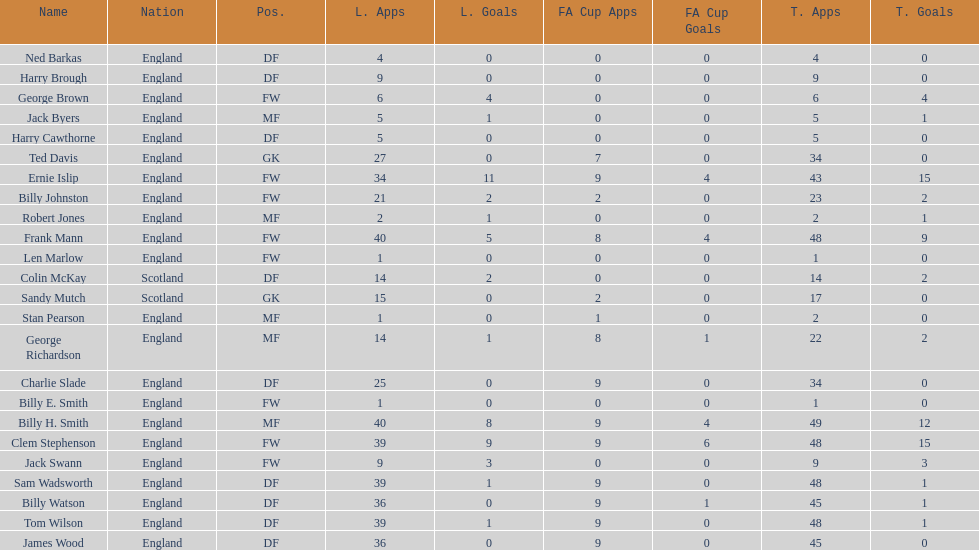Can you identify the first name listed? Ned Barkas. 